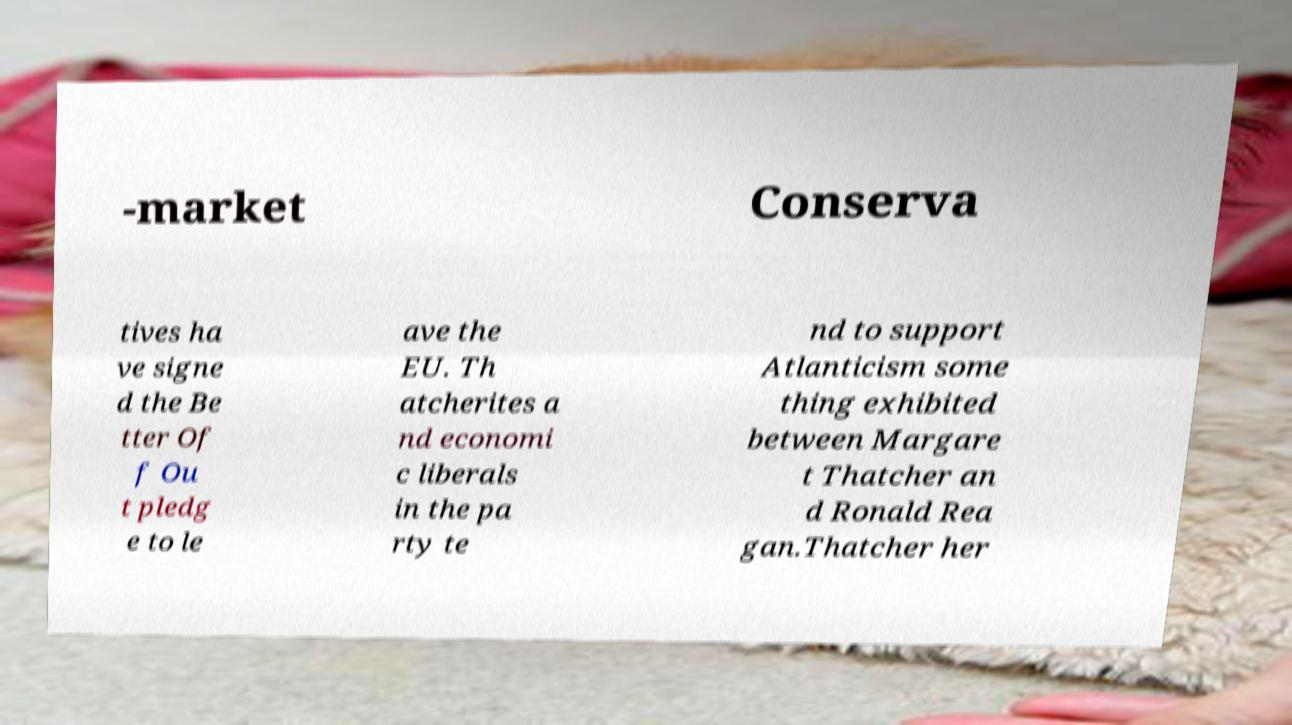Could you assist in decoding the text presented in this image and type it out clearly? -market Conserva tives ha ve signe d the Be tter Of f Ou t pledg e to le ave the EU. Th atcherites a nd economi c liberals in the pa rty te nd to support Atlanticism some thing exhibited between Margare t Thatcher an d Ronald Rea gan.Thatcher her 